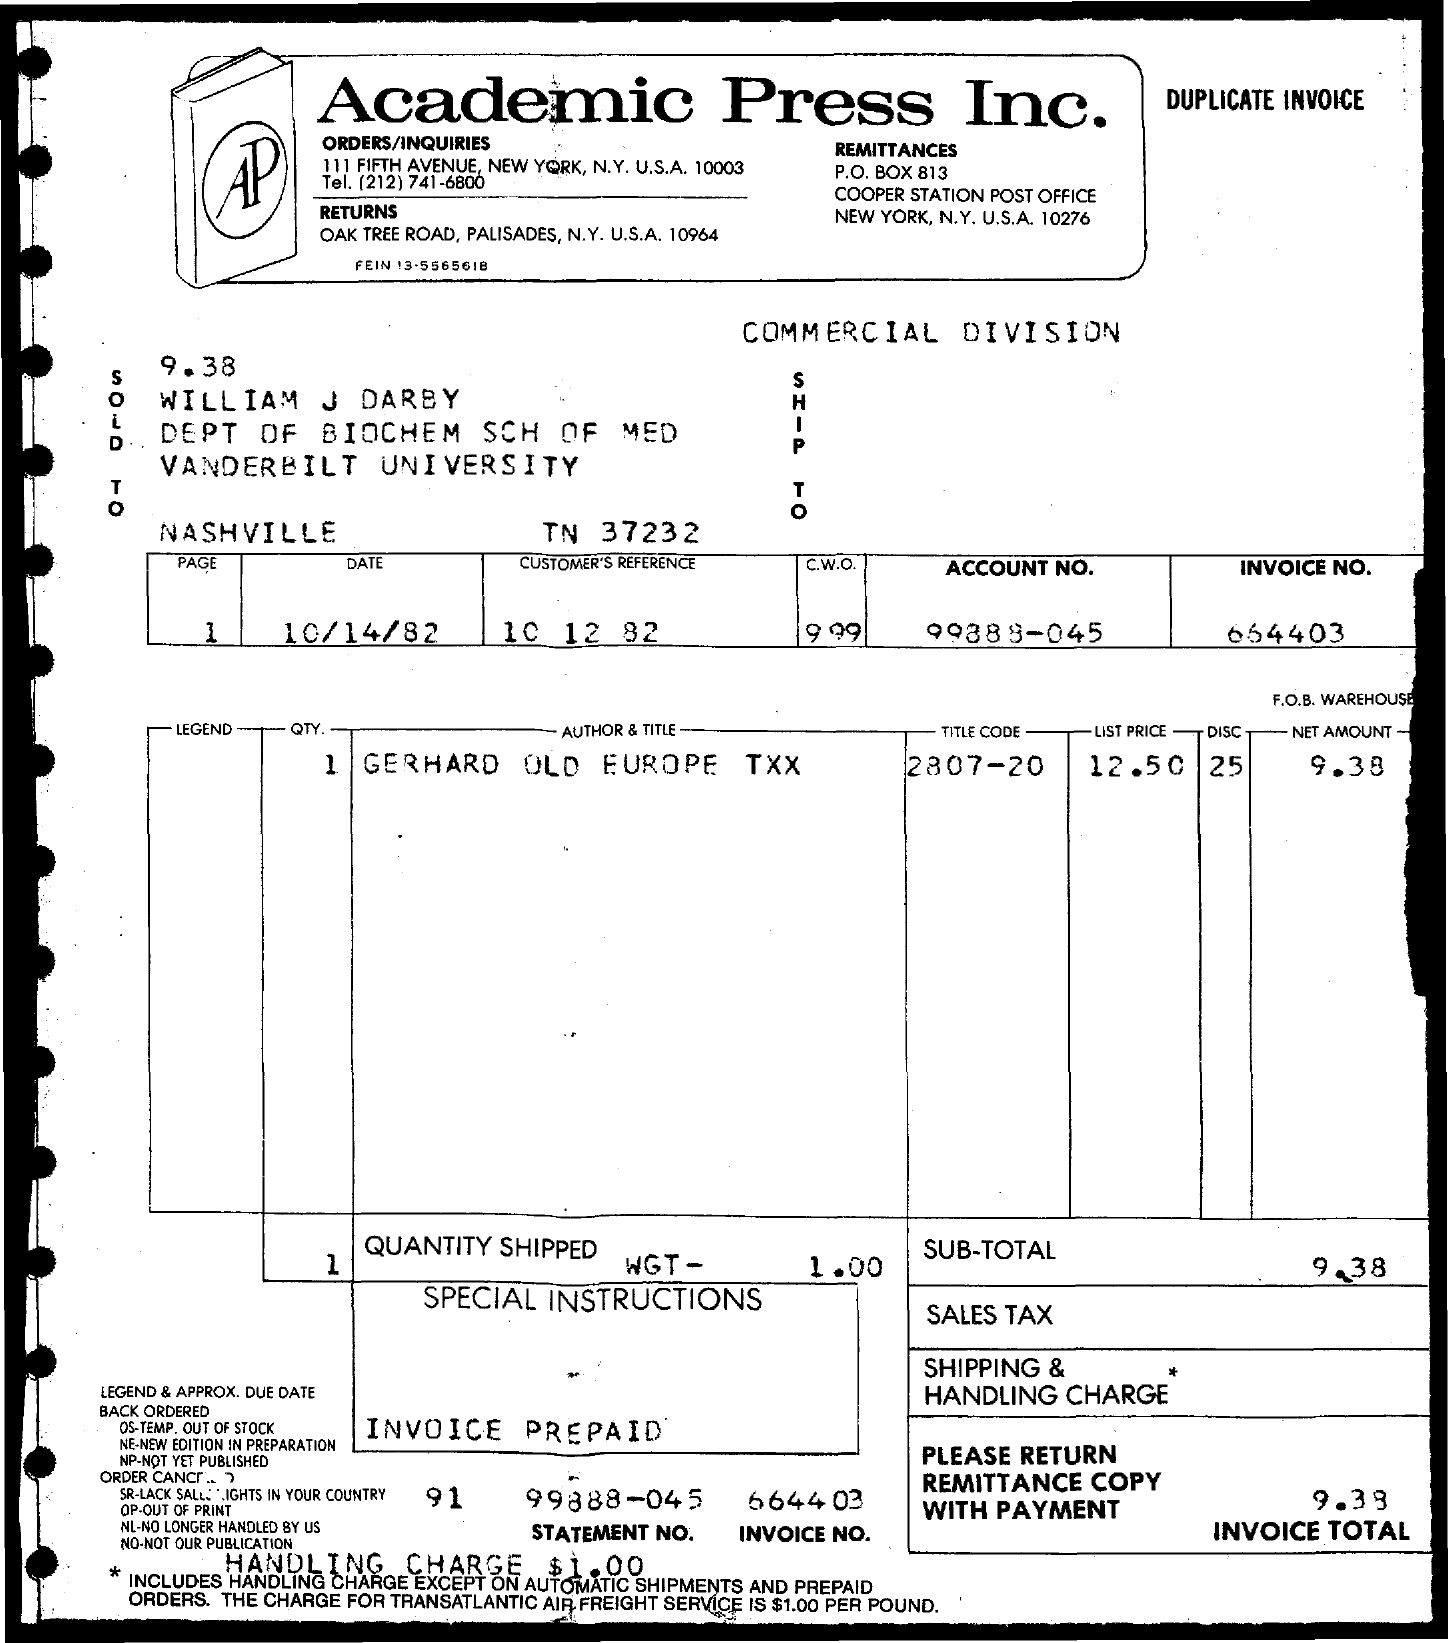What is the date?
Keep it short and to the point. 10/14/82. What is the customer reference?
Provide a succinct answer. 10 12 82. What is the account number?
Your answer should be very brief. 99888-045. What is the invoice no.?
Your answer should be very brief. 664403. What is the title code?
Ensure brevity in your answer.  2807-20. What is the list price?
Keep it short and to the point. 12.50. What is the net amount?
Make the answer very short. 9.38. 